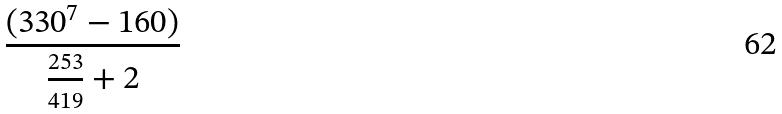Convert formula to latex. <formula><loc_0><loc_0><loc_500><loc_500>\frac { ( 3 3 0 ^ { 7 } - 1 6 0 ) } { \frac { 2 5 3 } { 4 1 9 } + 2 }</formula> 